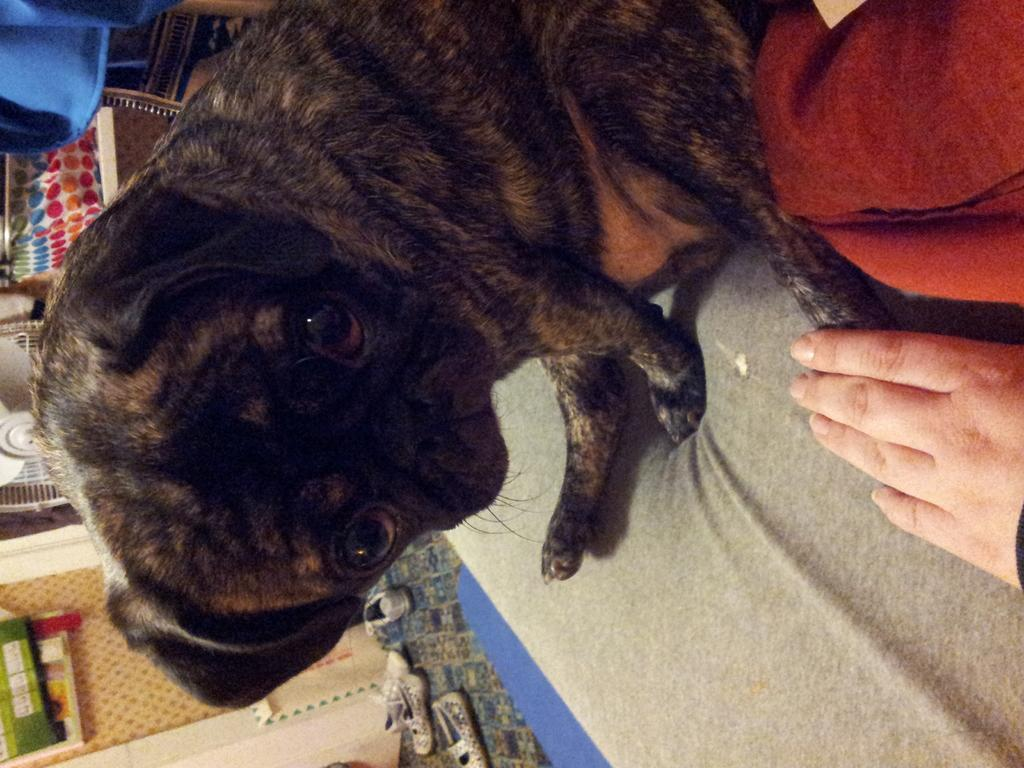What type of animal is on the surface in the image? There is a dog on the surface in the image. Whose hand is visible in the image? A person's hand is visible in the image. What is the purpose of the cloth in the image? The cloth might be used for cleaning or wiping in the image. What type of footwear is on the floor in the image? There are shoes on the floor in the image. What is on the wall in the image? There are posters on a wall in the image? What type of device is present in the image? A table fan is present in the image. What object might be used for carrying items in the image? There is a bag in the image. How many patches are visible on the dog in the image? There is no information about patches on the dog in the image. What type of dolls are sitting on the table in the image? There are no dolls present in the image. 